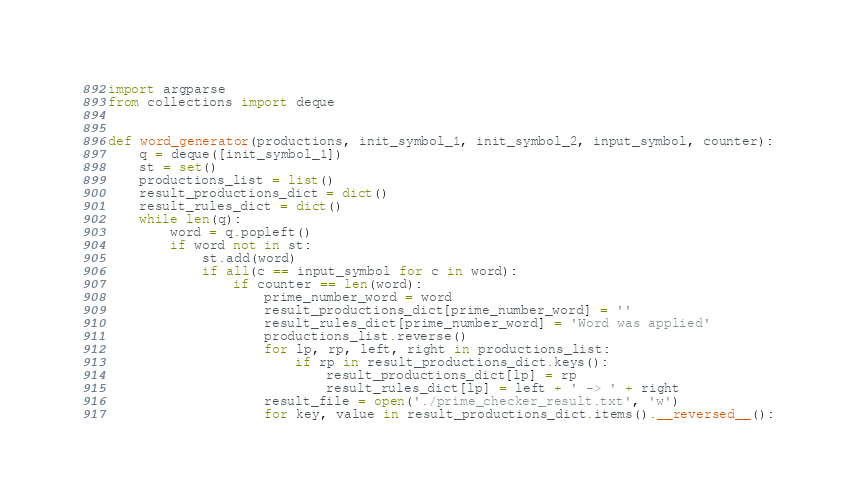Convert code to text. <code><loc_0><loc_0><loc_500><loc_500><_Python_>import argparse
from collections import deque


def word_generator(productions, init_symbol_1, init_symbol_2, input_symbol, counter):
    q = deque([init_symbol_1])
    st = set()
    productions_list = list()
    result_productions_dict = dict()
    result_rules_dict = dict()
    while len(q):
        word = q.popleft()
        if word not in st:
            st.add(word)
            if all(c == input_symbol for c in word):
                if counter == len(word):
                    prime_number_word = word
                    result_productions_dict[prime_number_word] = ''
                    result_rules_dict[prime_number_word] = 'Word was applied'
                    productions_list.reverse()
                    for lp, rp, left, right in productions_list:
                        if rp in result_productions_dict.keys():
                            result_productions_dict[lp] = rp
                            result_rules_dict[lp] = left + ' -> ' + right
                    result_file = open('./prime_checker_result.txt', 'w')
                    for key, value in result_productions_dict.items().__reversed__():</code> 